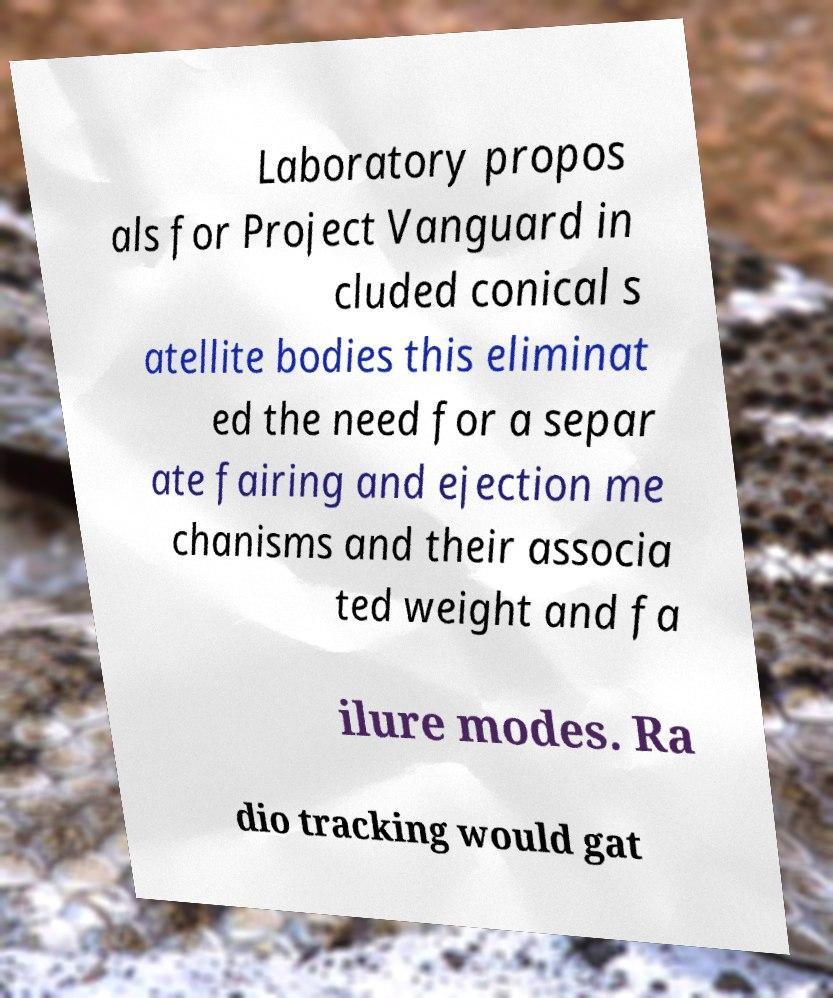Could you extract and type out the text from this image? Laboratory propos als for Project Vanguard in cluded conical s atellite bodies this eliminat ed the need for a separ ate fairing and ejection me chanisms and their associa ted weight and fa ilure modes. Ra dio tracking would gat 